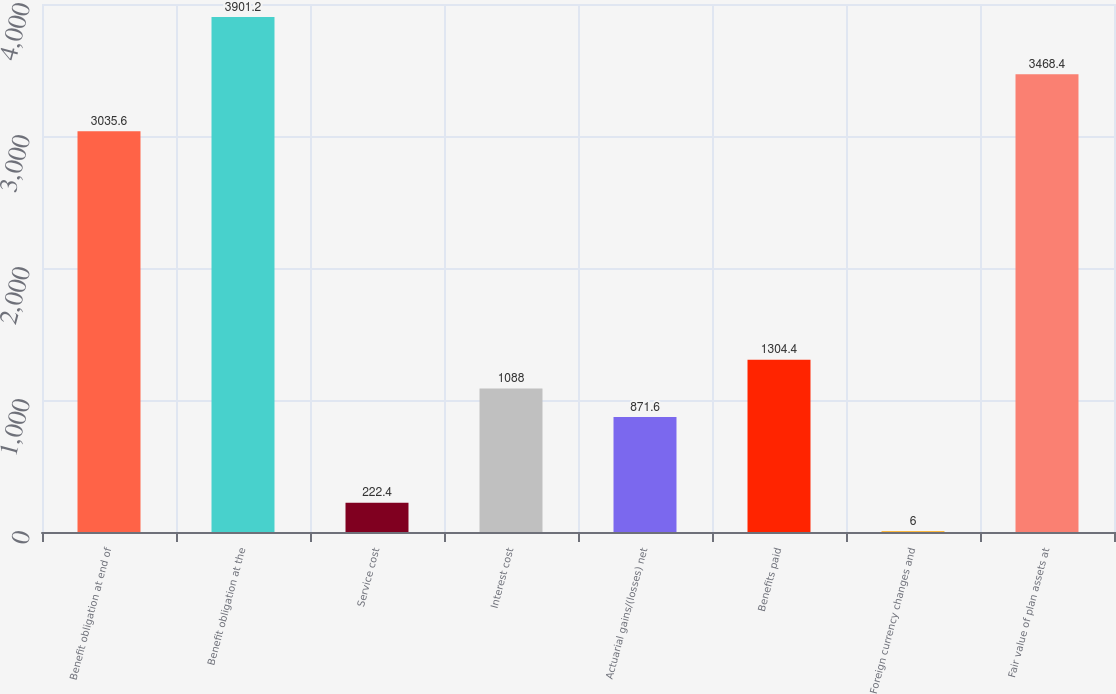Convert chart to OTSL. <chart><loc_0><loc_0><loc_500><loc_500><bar_chart><fcel>Benefit obligation at end of<fcel>Benefit obligation at the<fcel>Service cost<fcel>Interest cost<fcel>Actuarial gains/(losses) net<fcel>Benefits paid<fcel>Foreign currency changes and<fcel>Fair value of plan assets at<nl><fcel>3035.6<fcel>3901.2<fcel>222.4<fcel>1088<fcel>871.6<fcel>1304.4<fcel>6<fcel>3468.4<nl></chart> 